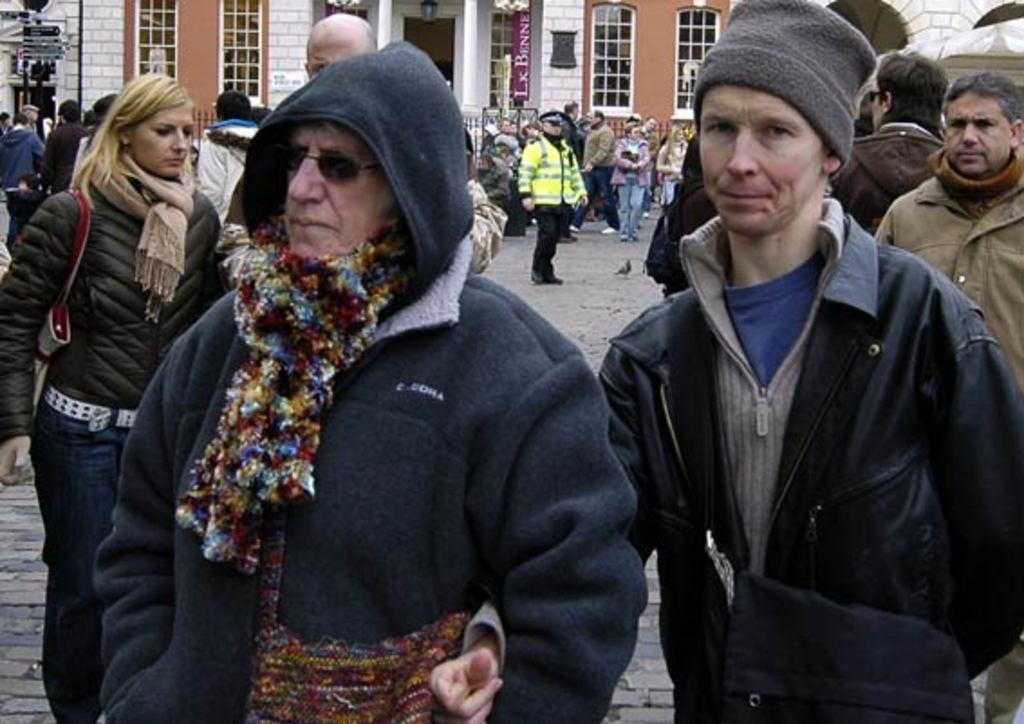What can be seen on the right side of the image? There are people on the right side of the image. What can be seen on the left side of the image? There are people on the left side of the image. What is the central figure in the image? There is a cop in the center of the image. What type of structure is visible at the top side of the image? There is a building at the top side of the image. What type of brick is the cop using to brush his teeth in the image? There is no toothbrush or toothpaste present in the image, and the cop is not brushing his teeth. What type of fire can be seen in the image? There is no fire present in the image. 